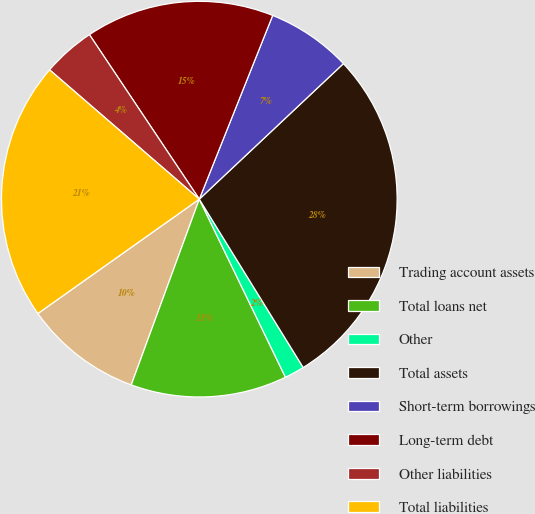Convert chart. <chart><loc_0><loc_0><loc_500><loc_500><pie_chart><fcel>Trading account assets<fcel>Total loans net<fcel>Other<fcel>Total assets<fcel>Short-term borrowings<fcel>Long-term debt<fcel>Other liabilities<fcel>Total liabilities<nl><fcel>9.6%<fcel>12.76%<fcel>1.63%<fcel>28.21%<fcel>6.94%<fcel>15.42%<fcel>4.29%<fcel>21.15%<nl></chart> 